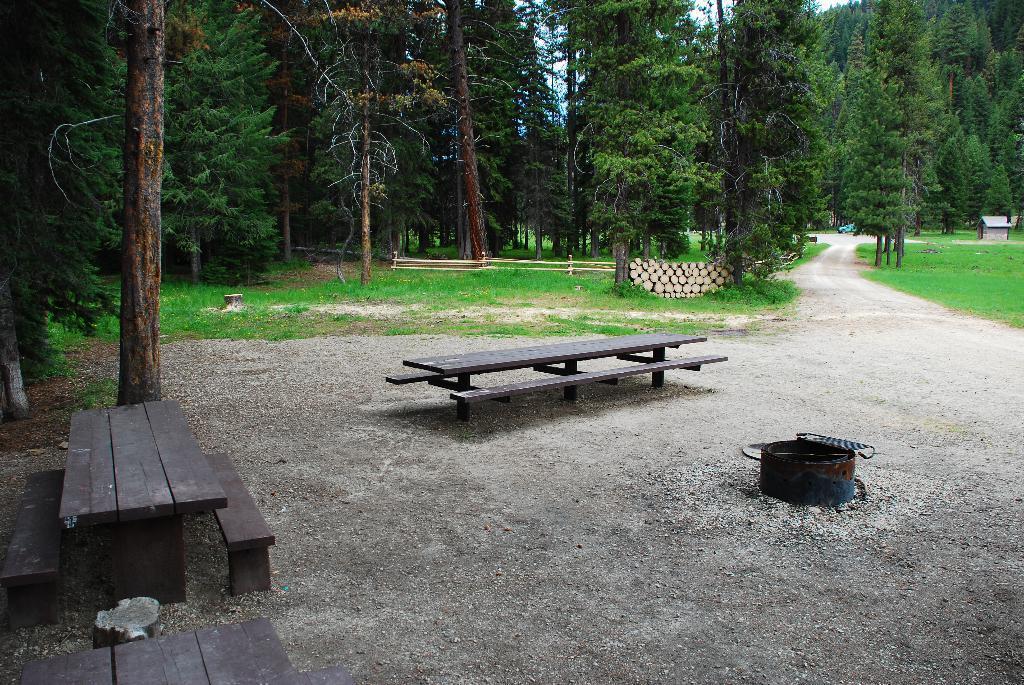How would you summarize this image in a sentence or two? There are wooden benches in the foreground area of the image and an object on the right side. There are trees, grassland, railing, house, vehicle and sky in the background area. 